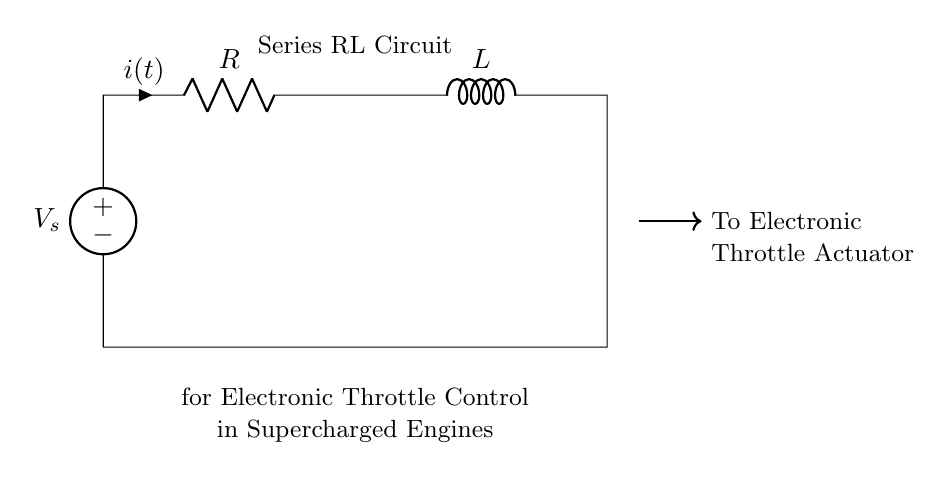What type of circuit is this? The circuit is described as a Series RL Circuit, indicating the components are connected in series with a resistor and an inductor.
Answer: Series RL Circuit What are the two main components in the circuit? The circuit contains a resistor and an inductor, which are the primary components used in a series RL circuit.
Answer: Resistor and Inductor What is connected to the output of the inductor? The output from the inductor is connected to the Electronic Throttle Actuator, which is responsible for controlling throttle position.
Answer: Electronic Throttle Actuator What does the voltage source represent? The voltage source represents the supply voltage, which powers the series RL circuit to operate the electronic throttle control system.
Answer: Voltage source What happens to current when the voltage is applied to this circuit? When the voltage is applied, the current will gradually increase due to the inductor's property to oppose changes in current flow, demonstrating an exponential rise.
Answer: Gradually increases Why is an inductor used in this circuit? An inductor is used to manage the rate of current change, providing smooth control of the throttle actuator and preventing rapid fluctuations which could be harmful.
Answer: To manage current change 